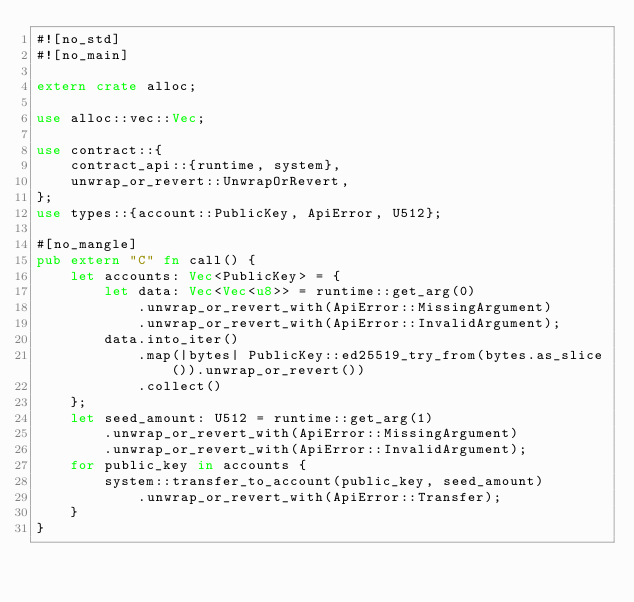Convert code to text. <code><loc_0><loc_0><loc_500><loc_500><_Rust_>#![no_std]
#![no_main]

extern crate alloc;

use alloc::vec::Vec;

use contract::{
    contract_api::{runtime, system},
    unwrap_or_revert::UnwrapOrRevert,
};
use types::{account::PublicKey, ApiError, U512};

#[no_mangle]
pub extern "C" fn call() {
    let accounts: Vec<PublicKey> = {
        let data: Vec<Vec<u8>> = runtime::get_arg(0)
            .unwrap_or_revert_with(ApiError::MissingArgument)
            .unwrap_or_revert_with(ApiError::InvalidArgument);
        data.into_iter()
            .map(|bytes| PublicKey::ed25519_try_from(bytes.as_slice()).unwrap_or_revert())
            .collect()
    };
    let seed_amount: U512 = runtime::get_arg(1)
        .unwrap_or_revert_with(ApiError::MissingArgument)
        .unwrap_or_revert_with(ApiError::InvalidArgument);
    for public_key in accounts {
        system::transfer_to_account(public_key, seed_amount)
            .unwrap_or_revert_with(ApiError::Transfer);
    }
}
</code> 